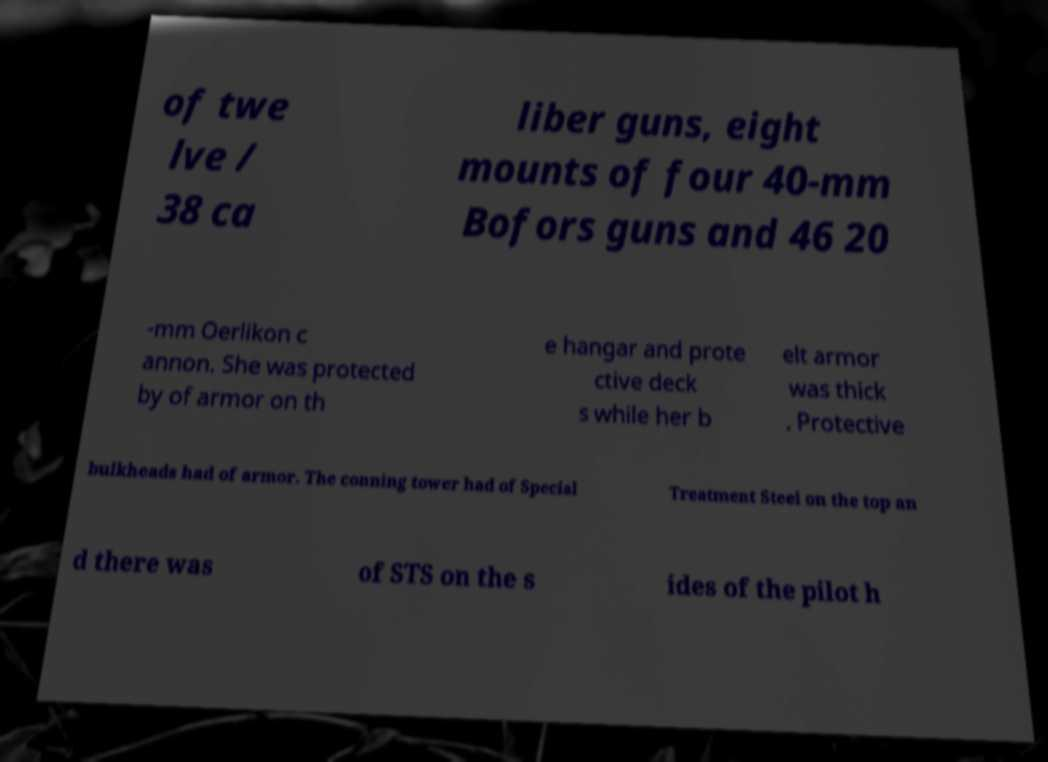I need the written content from this picture converted into text. Can you do that? of twe lve / 38 ca liber guns, eight mounts of four 40-mm Bofors guns and 46 20 -mm Oerlikon c annon. She was protected by of armor on th e hangar and prote ctive deck s while her b elt armor was thick . Protective bulkheads had of armor. The conning tower had of Special Treatment Steel on the top an d there was of STS on the s ides of the pilot h 